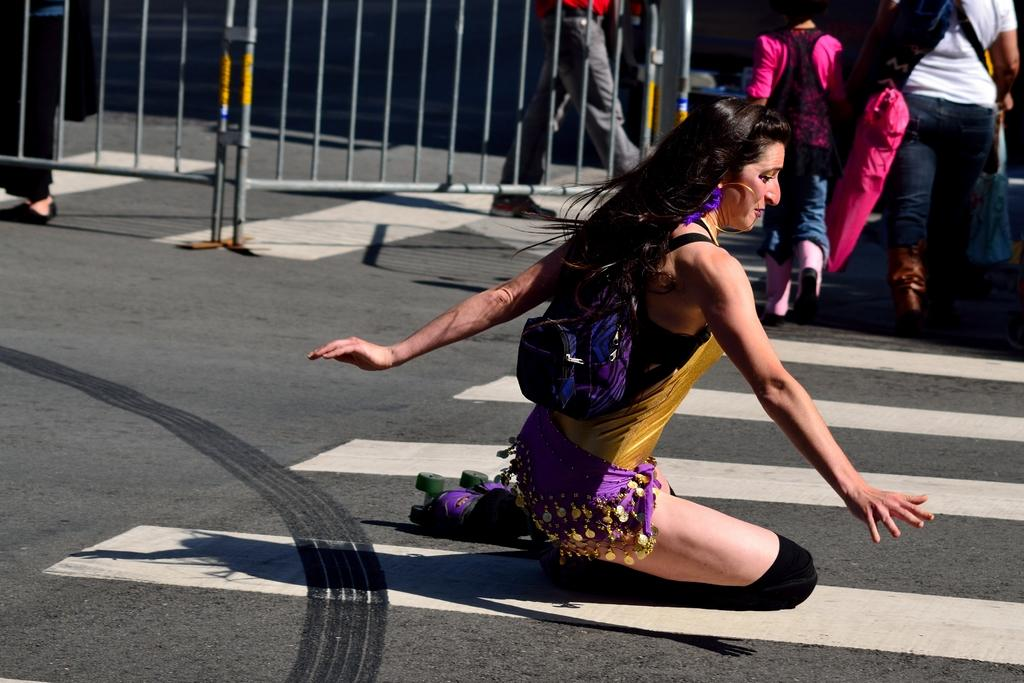What is the woman in the image doing? The woman is sitting in the image. What can be seen happening on the road in the image? There are people walking on the road in the image. What structures are visible at the top of the image? There are barricades visible at the top of the image. What type of body of water is visible in the image? There is no body of water present in the image. How is the water distributed in the basin in the image? There is no basin or water present in the image. 